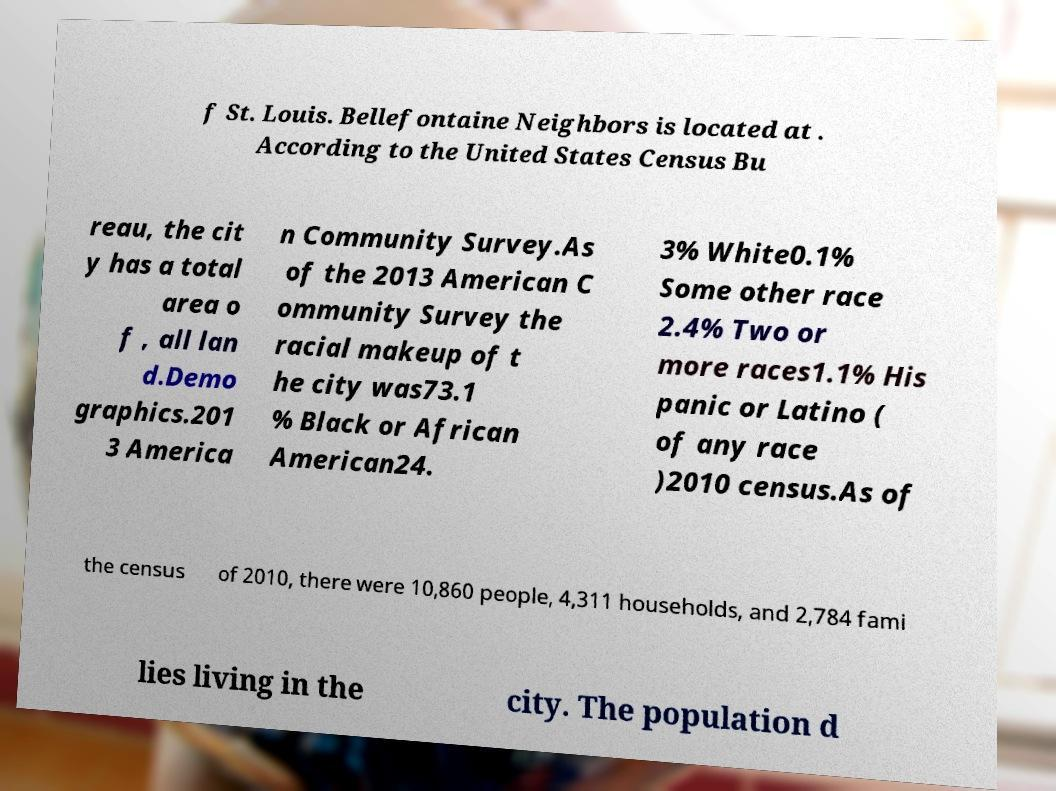What messages or text are displayed in this image? I need them in a readable, typed format. f St. Louis. Bellefontaine Neighbors is located at . According to the United States Census Bu reau, the cit y has a total area o f , all lan d.Demo graphics.201 3 America n Community Survey.As of the 2013 American C ommunity Survey the racial makeup of t he city was73.1 % Black or African American24. 3% White0.1% Some other race 2.4% Two or more races1.1% His panic or Latino ( of any race )2010 census.As of the census of 2010, there were 10,860 people, 4,311 households, and 2,784 fami lies living in the city. The population d 